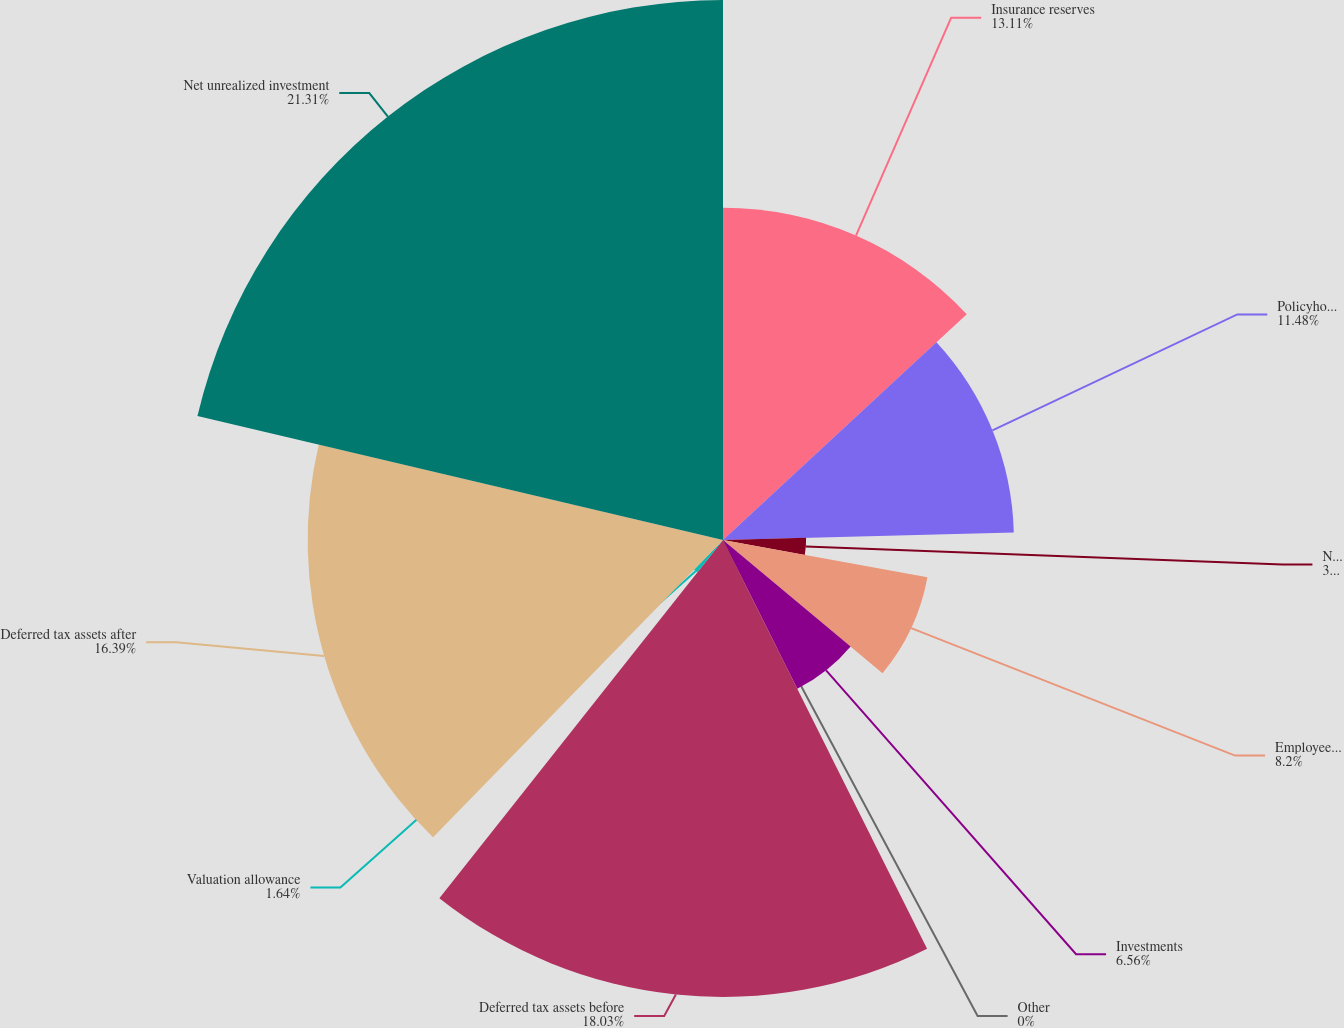<chart> <loc_0><loc_0><loc_500><loc_500><pie_chart><fcel>Insurance reserves<fcel>Policyholders' dividends<fcel>Net operating and capital loss<fcel>Employee benefits<fcel>Investments<fcel>Other<fcel>Deferred tax assets before<fcel>Valuation allowance<fcel>Deferred tax assets after<fcel>Net unrealized investment<nl><fcel>13.11%<fcel>11.48%<fcel>3.28%<fcel>8.2%<fcel>6.56%<fcel>0.0%<fcel>18.03%<fcel>1.64%<fcel>16.39%<fcel>21.31%<nl></chart> 